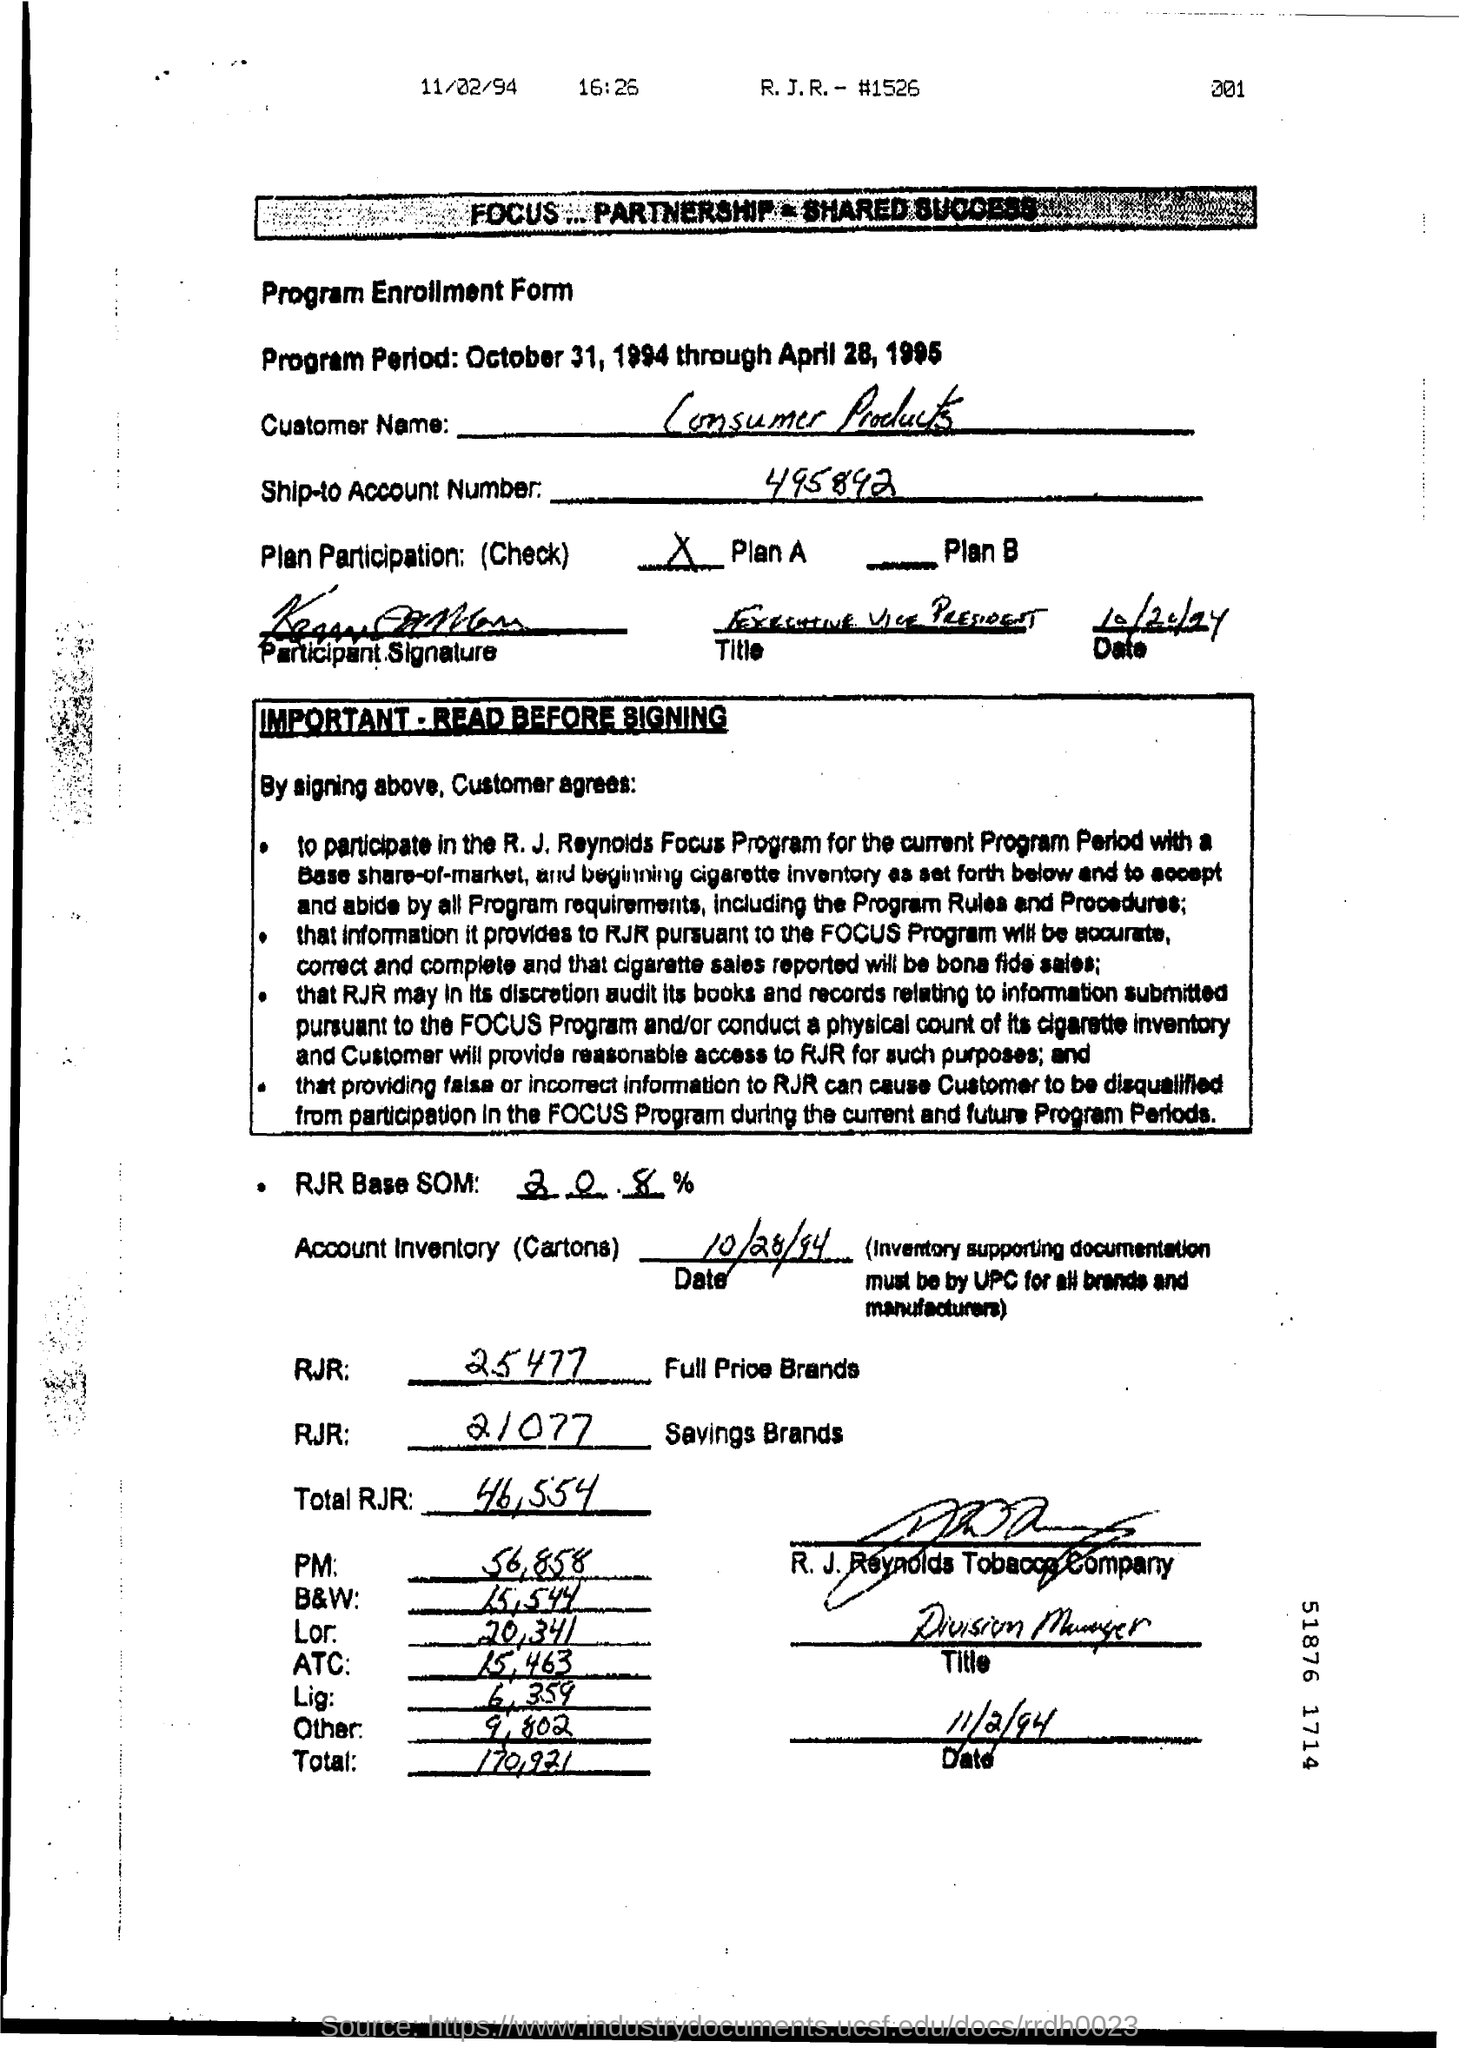What is the Program Period mentioned in the form?
Offer a terse response. October 31, 1994 through April 28, 1995. What is Ship-to Account Number ?
Ensure brevity in your answer.  495892. What is written in the RJR field for Full  Price Brands ?
Your response must be concise. 25477. What is the date mentioned in the bottom of the document ?
Make the answer very short. 11/2/94. What is written in the RJR field  for Savings Brands ?
Offer a terse response. 21077. What is the account inventory date ?
Provide a short and direct response. 10/28/94. What is written in the  Other Field ?
Offer a terse response. 9,802. What is written in the ATC Field ?
Your answer should be very brief. 15,463. 